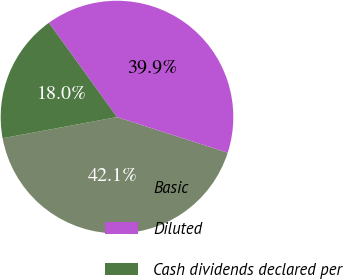<chart> <loc_0><loc_0><loc_500><loc_500><pie_chart><fcel>Basic<fcel>Diluted<fcel>Cash dividends declared per<nl><fcel>42.14%<fcel>39.9%<fcel>17.96%<nl></chart> 